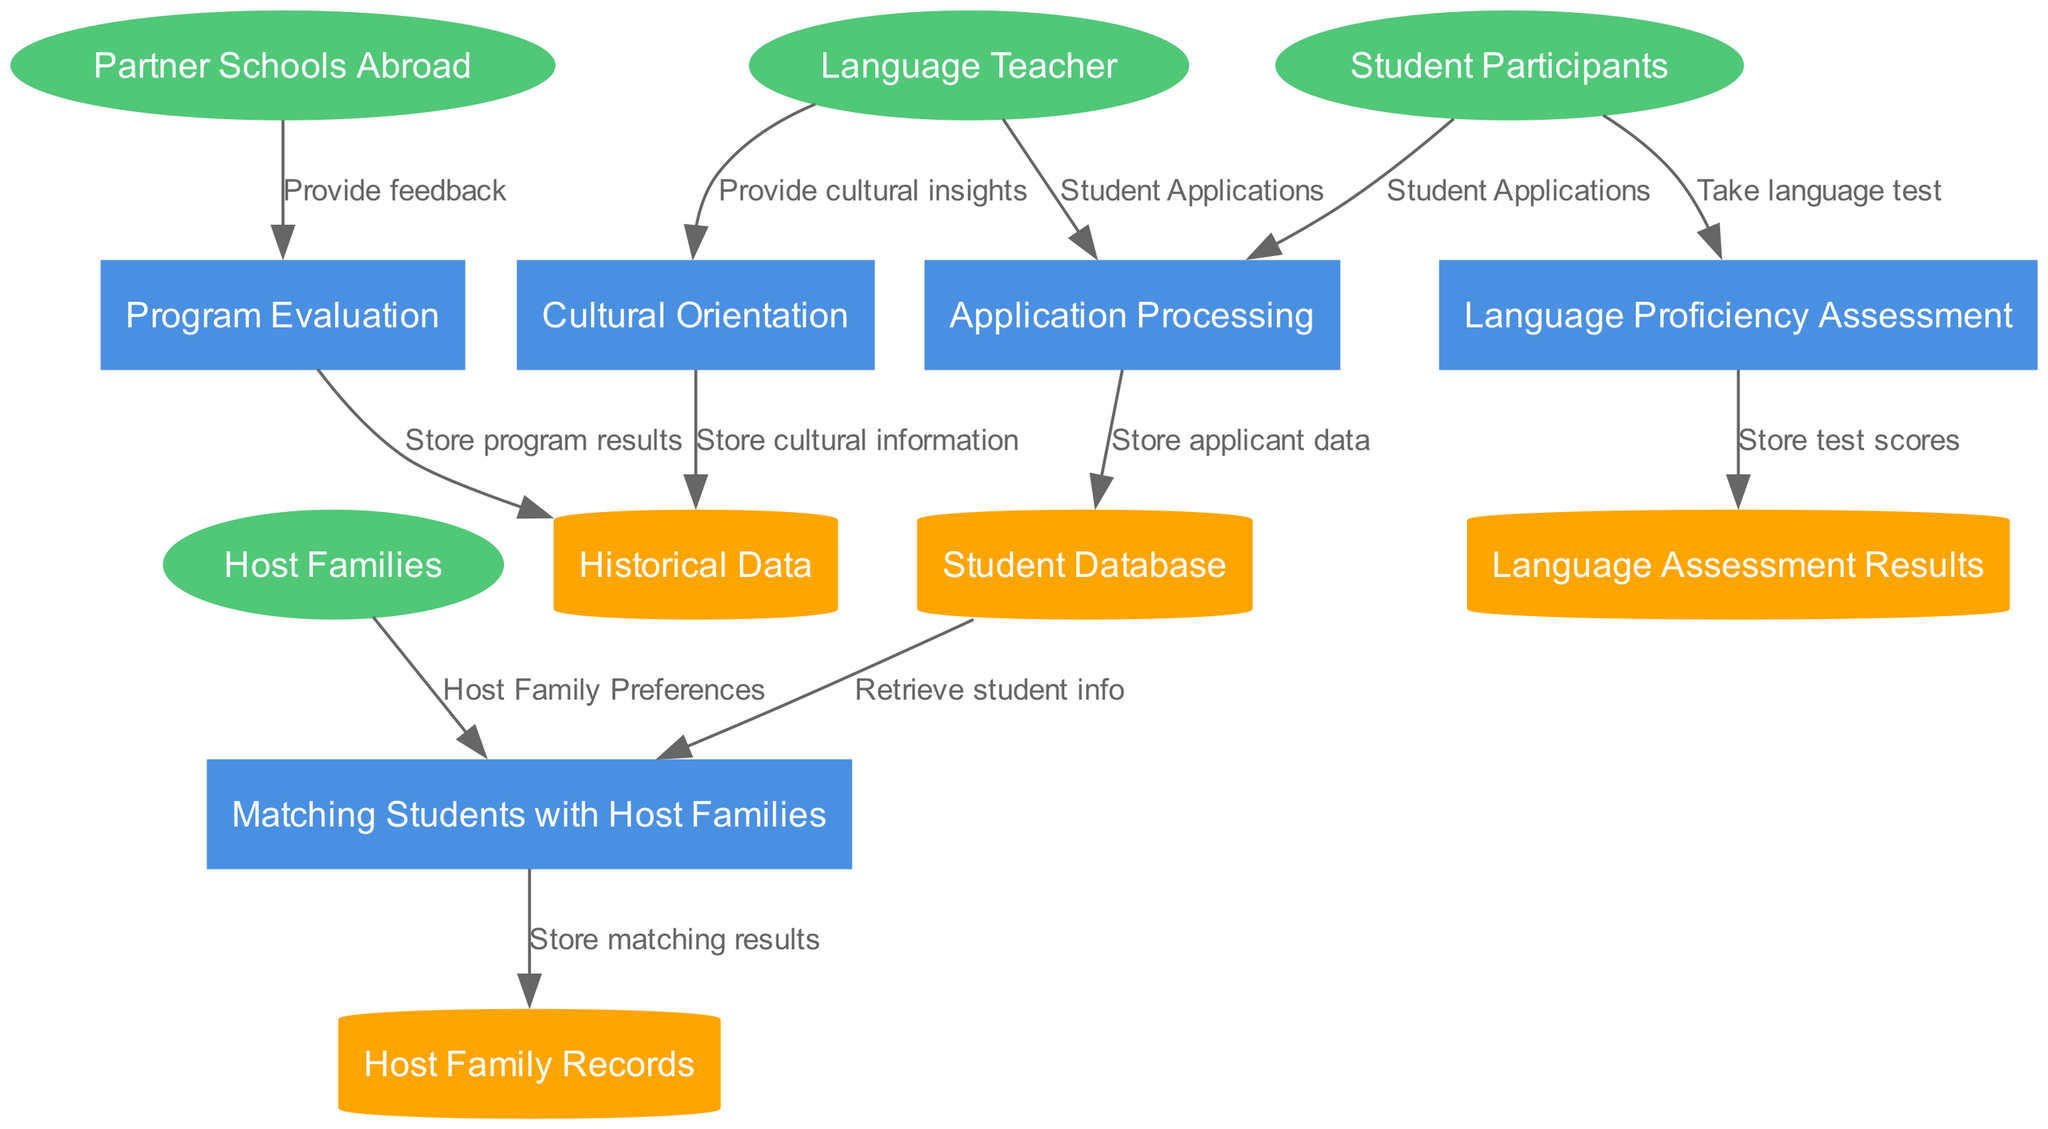What are the external entities in the diagram? The diagram identifies four external entities, which are: Language Teacher, Student Participants, Host Families, and Partner Schools Abroad.
Answer: Language Teacher, Student Participants, Host Families, Partner Schools Abroad How many processes are there? The diagram includes five distinct processes: Application Processing, Matching Students with Host Families, Language Proficiency Assessment, Cultural Orientation, and Program Evaluation. Thus, the total number of processes is five.
Answer: Five What data flows from the Language Teacher to Application Processing? The data flow from the Language Teacher to Application Processing is specifically labeled as Student Applications. This flow indicates that the Language Teacher provides applications submitted by students.
Answer: Student Applications Which process stores the applicant data? The process that stores the applicant data is Application Processing, which transfers the data to the Student Database for storage. This task is crucial in maintaining a record of applicants.
Answer: Application Processing What type of data is stored in the Host Family Records? The Host Family Records store Participant Matching Results, which detail the outcomes of the matching process between students and host families.
Answer: Participant Matching Results Which external entity provides feedback to the Program Evaluation process? The external entity that provides feedback to the Program Evaluation process is Partner Schools Abroad. This feedback is essential for assessing the program and identifying areas of improvement.
Answer: Partner Schools Abroad How do language test scores get stored? Language test scores are obtained from the Language Proficiency Assessment process, which then transfers this data to the Language Assessment Results data store, effectively recording the results of students' assessments.
Answer: Language Assessment Results What is the relationship between Cultural Orientation and Historical Data? The relationship between Cultural Orientation and Historical Data involves storing cultural information gained during the cultural orientation phase. This connection is vital for preserving cultural insights from the program.
Answer: Store cultural information What do the external entities and processes flow into? The flows from external entities and processes contribute to data stores such as the Student Database, Host Family Records, Historical Data, and Language Assessment Results, which collectively maintain the program's comprehensive data management.
Answer: Data stores 